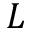Convert formula to latex. <formula><loc_0><loc_0><loc_500><loc_500>L</formula> 